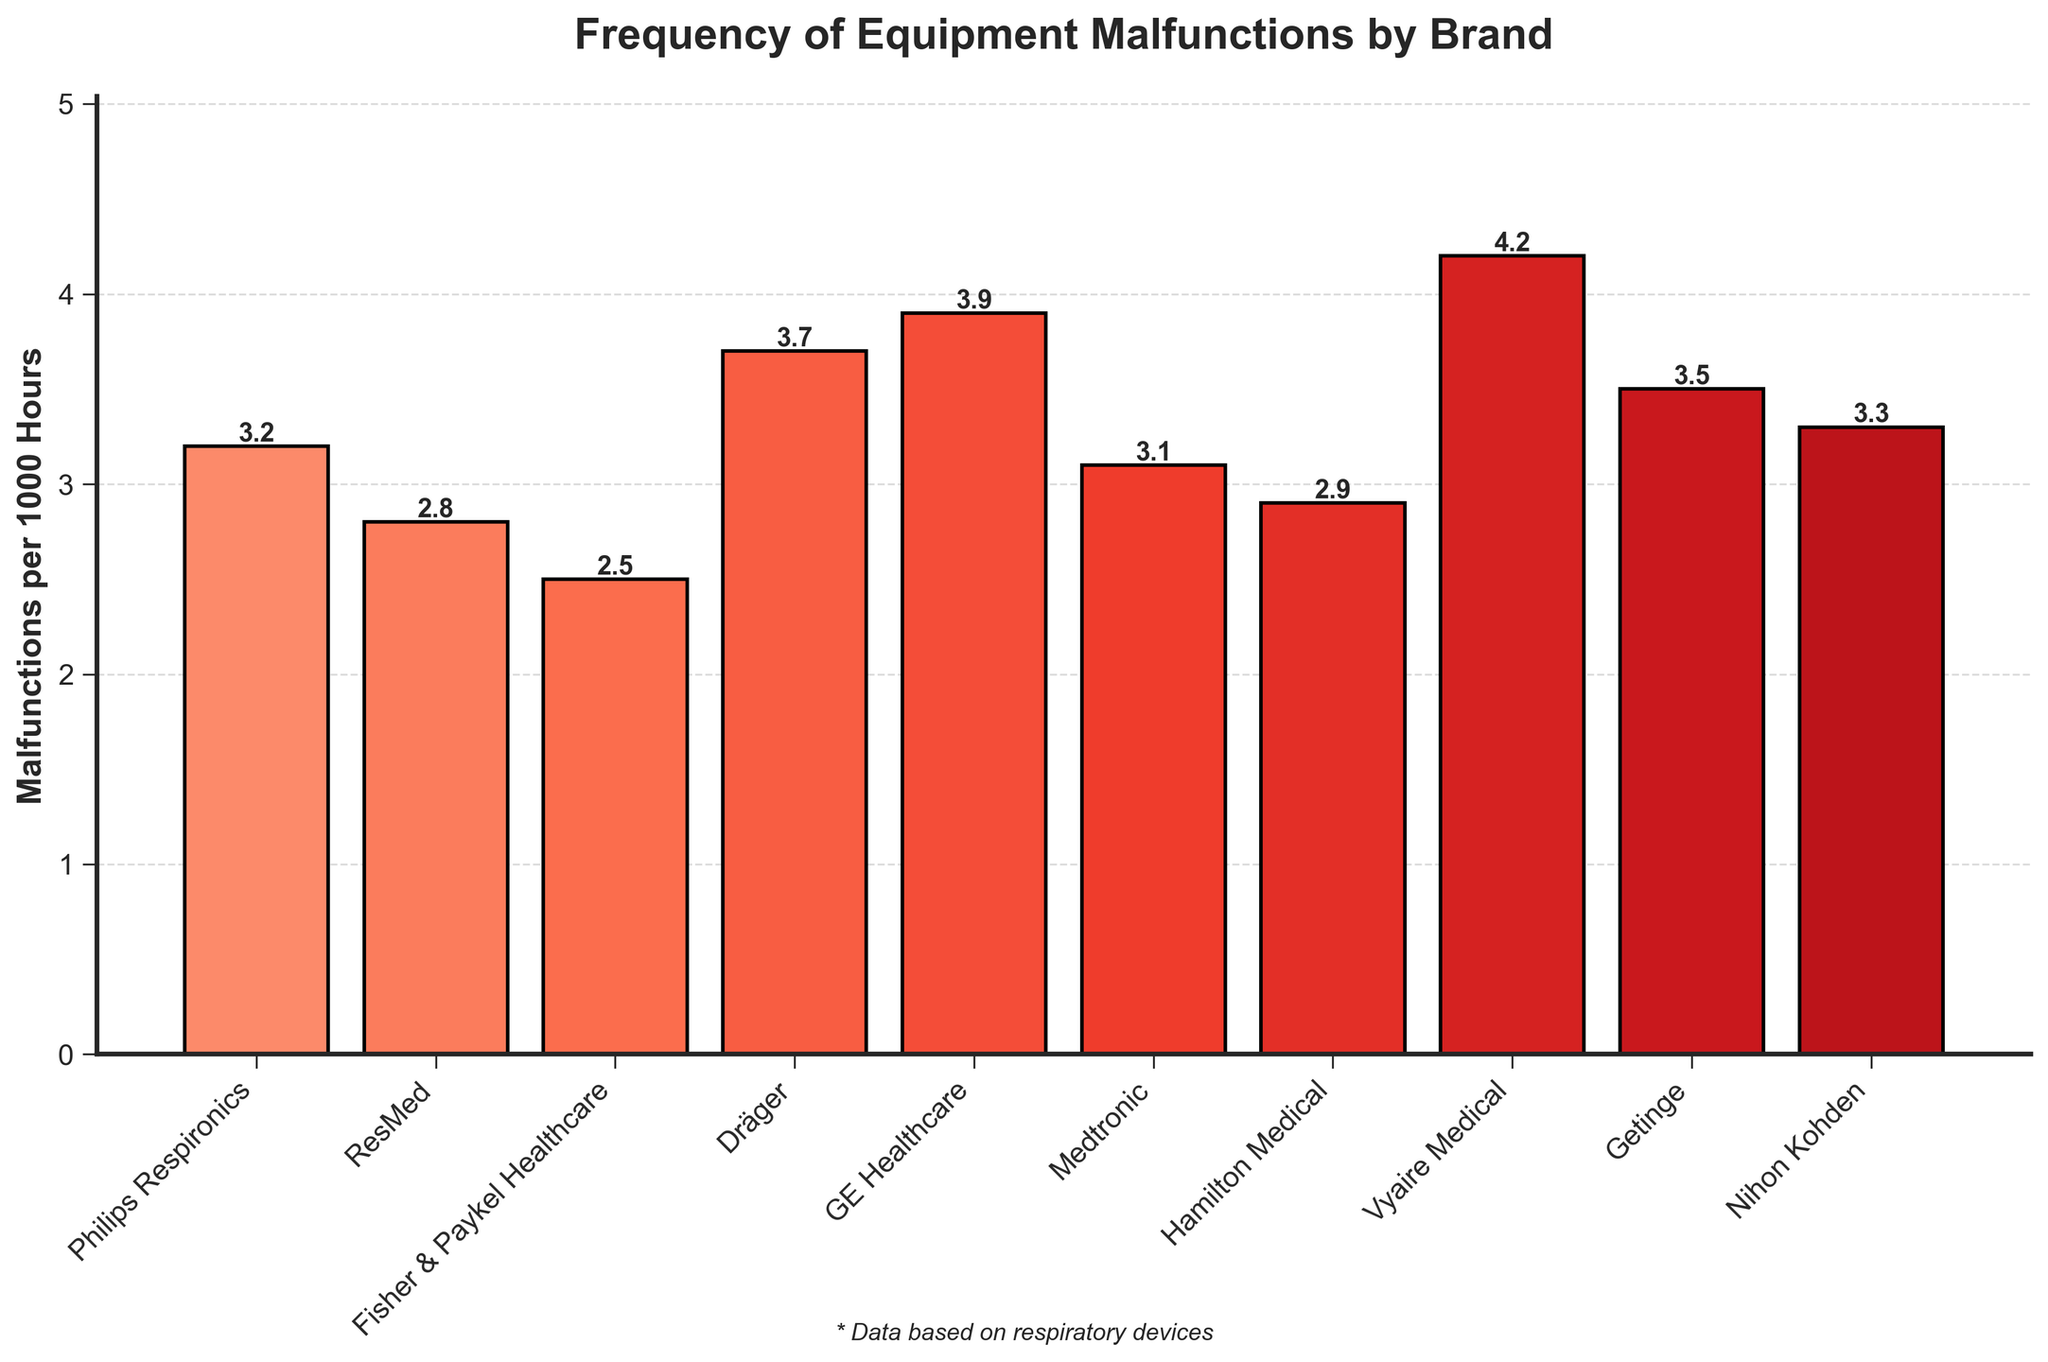What is the brand with the highest frequency of equipment malfunctions? By visually inspecting the heights of the bars, the bar for Vyaire Medical is the tallest, indicating the highest frequency of equipment malfunctions.
Answer: Vyaire Medical Which brand has fewer malfunctions, Dräger or Medtronic? By comparing the heights of the bars for Dräger and Medtronic, Medtronic has a lower value compared to Dräger.
Answer: Medtronic What is the difference in the frequency of malfunctions between Philips Respironics and GE Healthcare? The malfunction rate for Philips Respironics is 3.2, and for GE Healthcare it is 3.9. The difference is calculated as 3.9 - 3.2 = 0.7.
Answer: 0.7 Which brands have a malfunction rate less than 3 per 1000 hours? By examining the bars that are below the 3 mark on the y-axis, the brands are ResMed, Fisher & Paykel Healthcare, and Hamilton Medical.
Answer: ResMed, Fisher & Paykel Healthcare, Hamilton Medical What is the average malfunction rate across all brands? Sum the malfunction rates and divide by the number of brands. (3.2 + 2.8 + 2.5 + 3.7 + 3.9 + 3.1 + 2.9 + 4.2 + 3.5 + 3.3) / 10 = 3.31.
Answer: 3.31 Is Philips Respironics above or below the average malfunction rate? The average malfunction rate is 3.31, while Philips Respironics has a rate of 3.2, which is below the average.
Answer: Below Among the brands listed, which has the closest malfunction frequency to 3 malfunctions per 1000 hours? By inspecting the bars around the value of 3, Medtronic has a malfunction rate of 3.1, which is the closest to 3.
Answer: Medtronic How many brands have malfunction rates greater than 3.5 per 1000 hours? By counting the bars higher than the 3.5 mark on the y-axis, the brands are Dräger, GE Healthcare, and Vyaire Medical, making a total of 3 brands.
Answer: 3 Which brand has a malfunction frequency exactly 0.5 less than ResMed’s? ResMed has a malfunction rate of 2.8. Looking for a rate of 2.8 - 0.5 = 2.3, none of the listed brands match this criteria.
Answer: None 